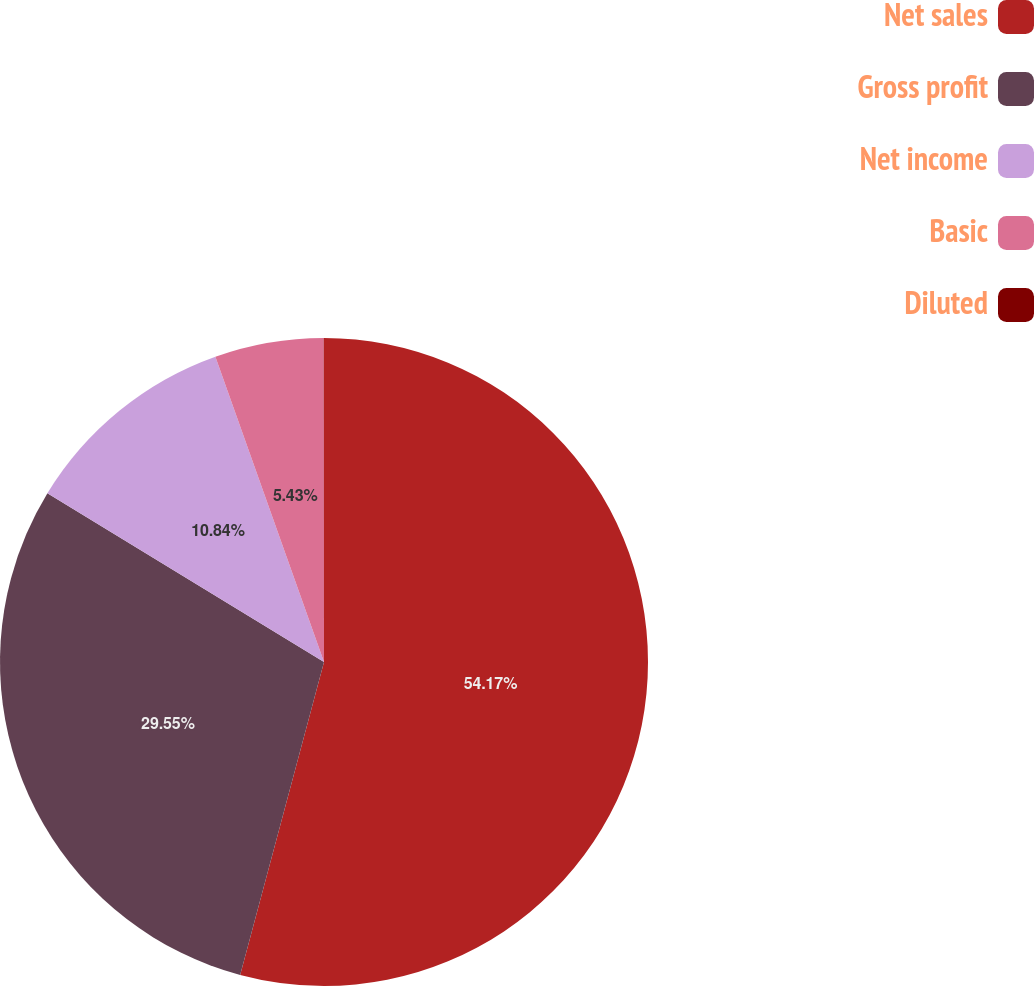<chart> <loc_0><loc_0><loc_500><loc_500><pie_chart><fcel>Net sales<fcel>Gross profit<fcel>Net income<fcel>Basic<fcel>Diluted<nl><fcel>54.16%<fcel>29.55%<fcel>10.84%<fcel>5.43%<fcel>0.01%<nl></chart> 